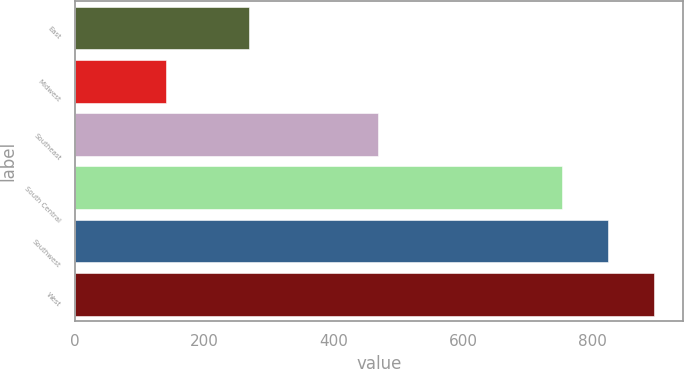<chart> <loc_0><loc_0><loc_500><loc_500><bar_chart><fcel>East<fcel>Midwest<fcel>Southeast<fcel>South Central<fcel>Southwest<fcel>West<nl><fcel>269.6<fcel>140.3<fcel>469<fcel>751.9<fcel>823<fcel>894.1<nl></chart> 